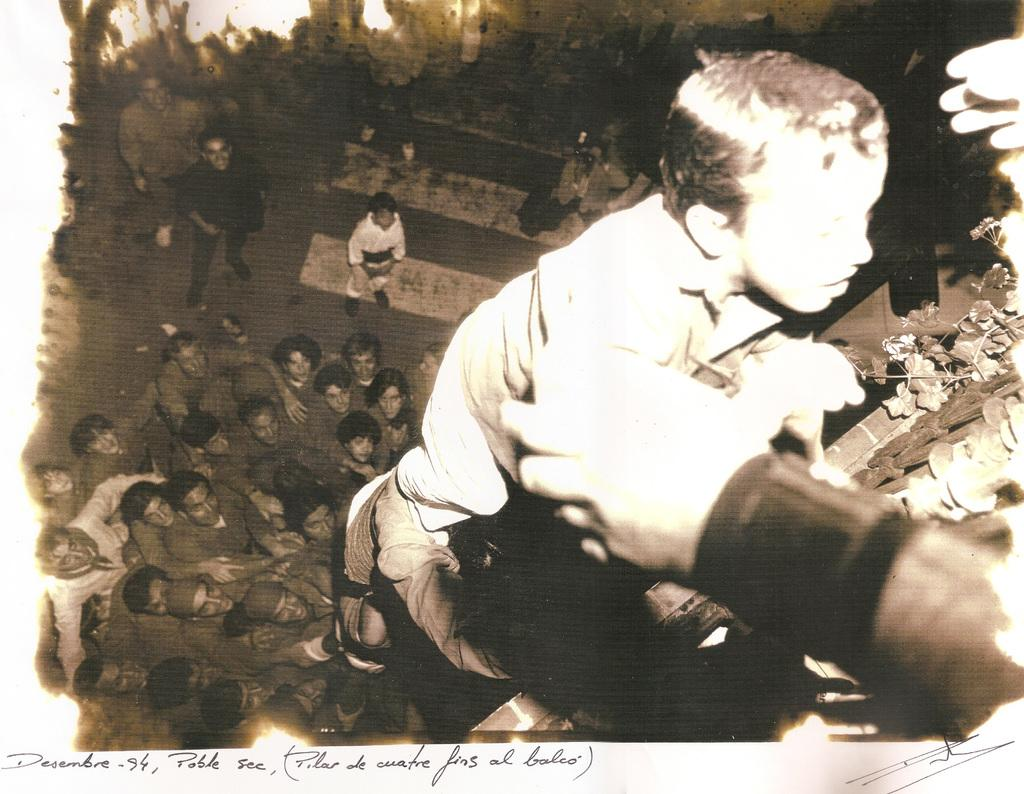What is the color scheme of the image? The image is black and white. Can you describe the subjects in the image? There is a group of people in the image. What type of unit is being used by the people in the image? There is no specific unit mentioned or visible in the image. Can you describe the coil or tub that is present in the image? There is no coil or tub present in the image; it only features a group of people. 